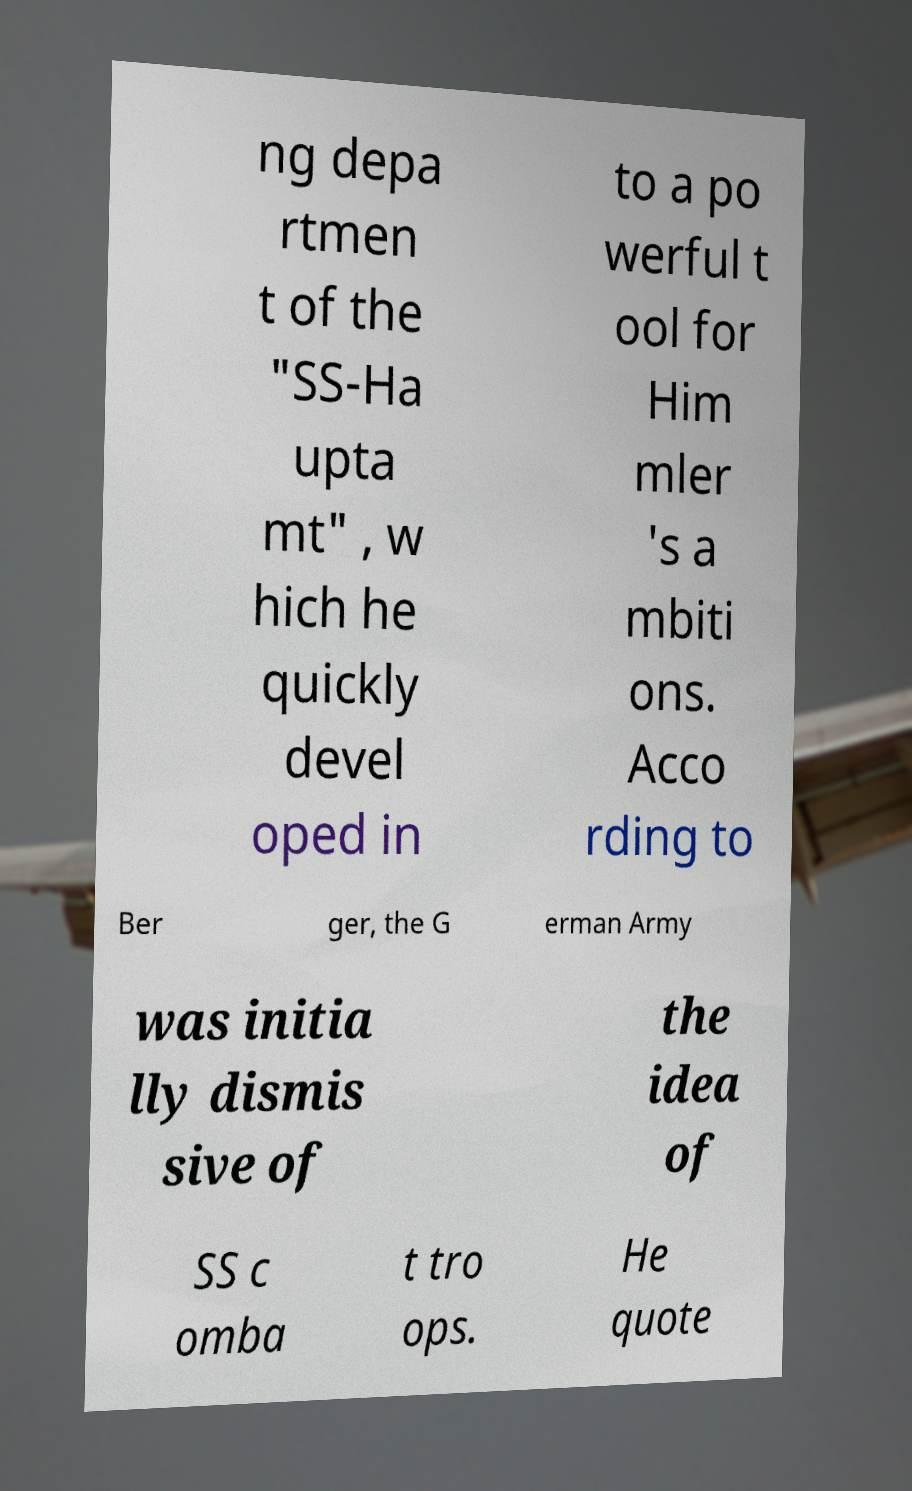Please identify and transcribe the text found in this image. ng depa rtmen t of the "SS-Ha upta mt" , w hich he quickly devel oped in to a po werful t ool for Him mler 's a mbiti ons. Acco rding to Ber ger, the G erman Army was initia lly dismis sive of the idea of SS c omba t tro ops. He quote 